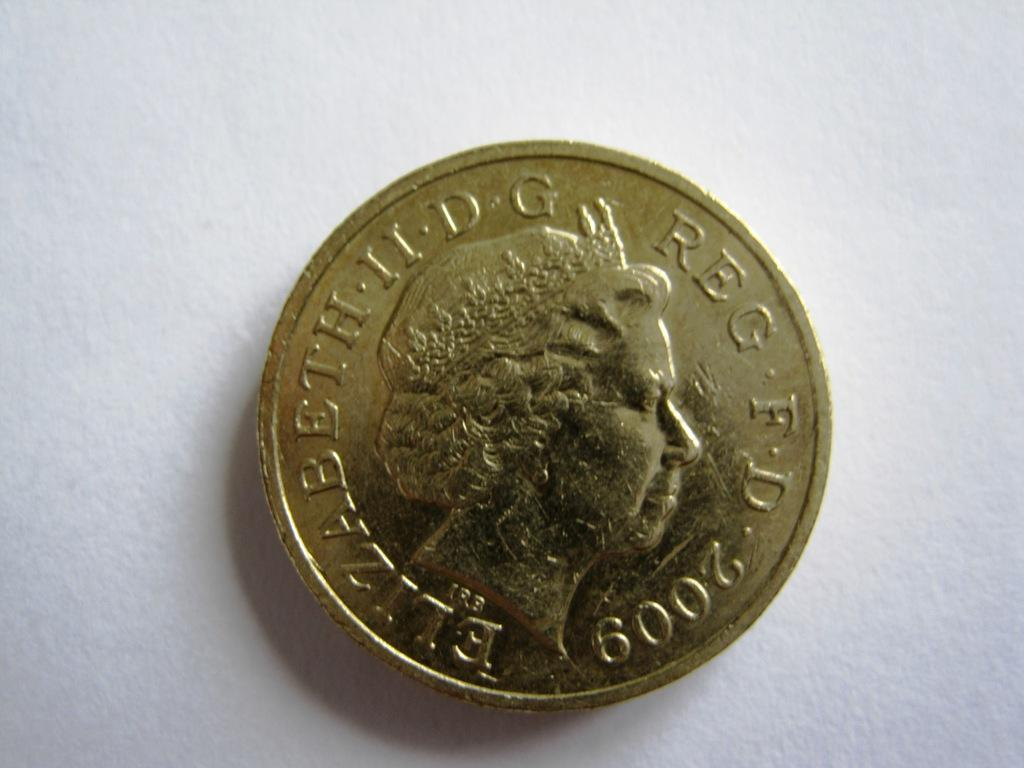<image>
Describe the image concisely. The gold coin shown here depicts Queen Elizabeth. 